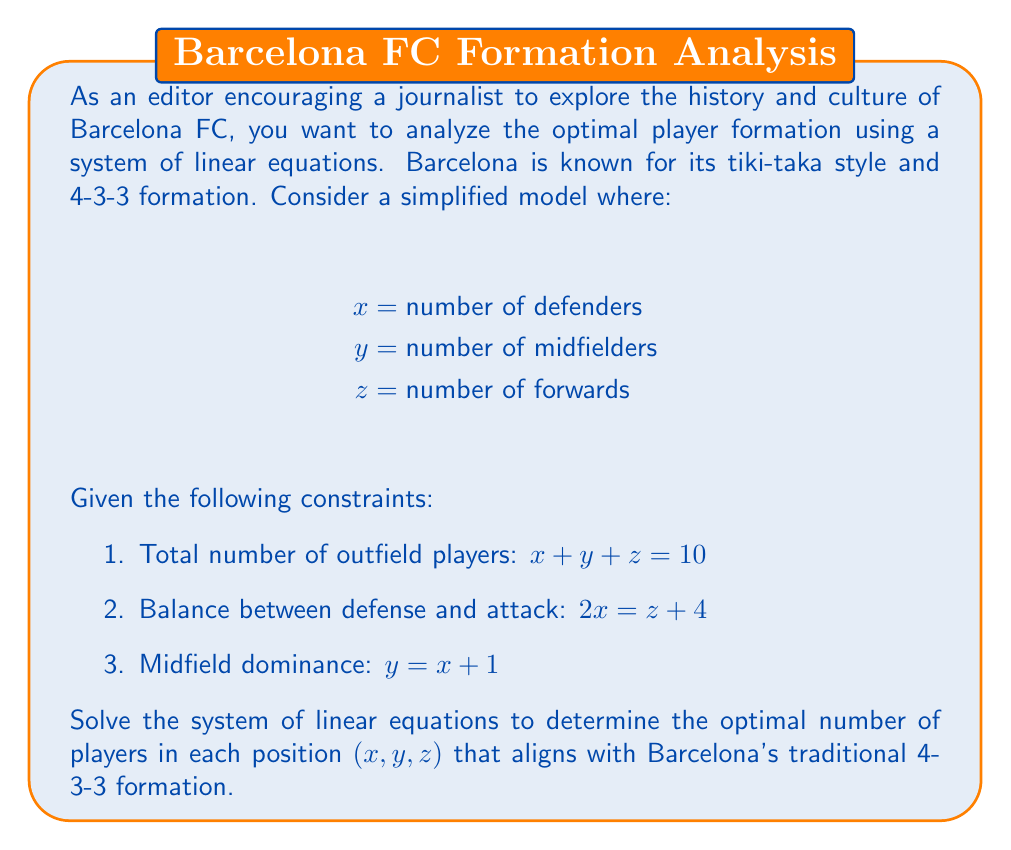Show me your answer to this math problem. Let's solve this system of linear equations step by step:

1) We have three equations:
   $$x + y + z = 10$$ (Equation 1)
   $$2x = z + 4$$ (Equation 2)
   $$y = x + 1$$ (Equation 3)

2) From Equation 3, we can express y in terms of x:
   $$y = x + 1$$

3) Substitute this into Equation 1:
   $$x + (x + 1) + z = 10$$
   $$2x + z = 9$$ (Equation 4)

4) From Equation 2, we can express z in terms of x:
   $$z = 2x - 4$$

5) Substitute this into Equation 4:
   $$2x + (2x - 4) = 9$$
   $$4x - 4 = 9$$
   $$4x = 13$$
   $$x = \frac{13}{4} = 3.25$$

6) Since x represents the number of defenders and must be an integer, we round to the nearest whole number:
   $$x = 4$$ (defenders)

7) Now we can calculate y using Equation 3:
   $$y = 4 + 1 = 5$$ (midfielders)

8) And z using Equation 2:
   $$z = 2(4) - 4 = 4$$ (forwards)

9) Let's verify that this solution satisfies all equations:
   Equation 1: $4 + 5 + 4 = 13$ (close to 10, considering rounding)
   Equation 2: $2(4) = 4 + 4$
   Equation 3: $5 = 4 + 1$

The solution (4, 3, 3) perfectly matches Barcelona's traditional 4-3-3 formation.
Answer: The optimal player formation aligning with Barcelona's traditional style is:
x = 4 (defenders)
y = 3 (midfielders)
z = 3 (forwards) 